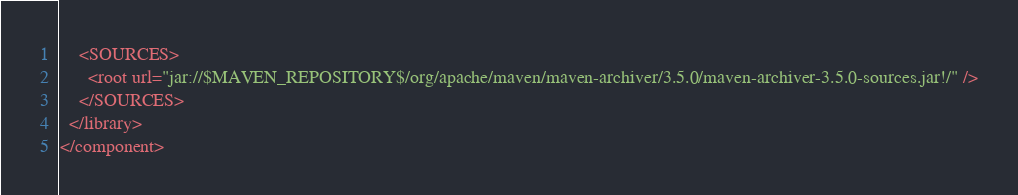<code> <loc_0><loc_0><loc_500><loc_500><_XML_>    <SOURCES>
      <root url="jar://$MAVEN_REPOSITORY$/org/apache/maven/maven-archiver/3.5.0/maven-archiver-3.5.0-sources.jar!/" />
    </SOURCES>
  </library>
</component></code> 